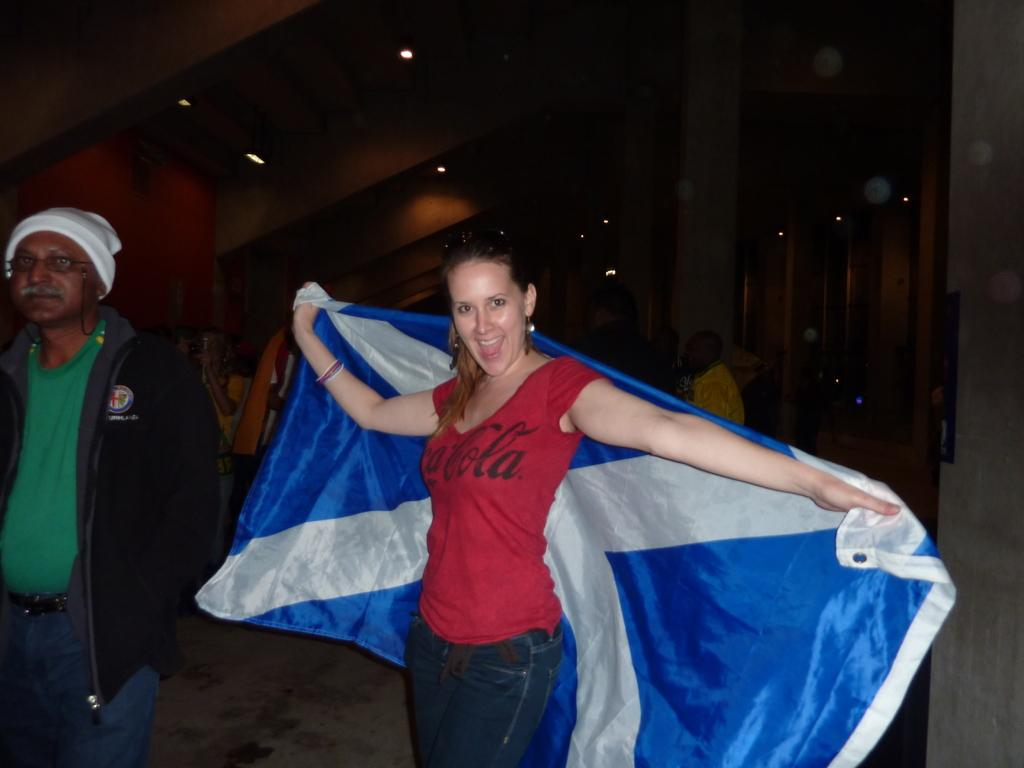Who is present in the image? There is a woman in the image. What is the woman doing in the image? The woman is standing and smiling in the image. What is the woman holding in the image? The woman is holding a flag in the image. Can you describe the group of people in the image? There is a group of people in the image, but their specific actions or characteristics are not mentioned in the provided facts. What can be seen in the background of the image? There are lights visible in the background of the image. What type of science experiment is being conducted by the woman in the image? There is no indication of a science experiment in the image; the woman is holding a flag and standing with a group of people. What drink is the woman holding in the image? The woman is not holding a drink in the image; she is holding a flag. 